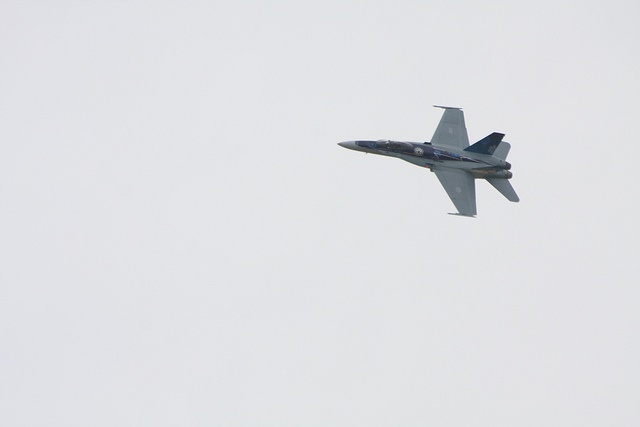Describe the objects in this image and their specific colors. I can see a airplane in lightgray, gray, and black tones in this image. 